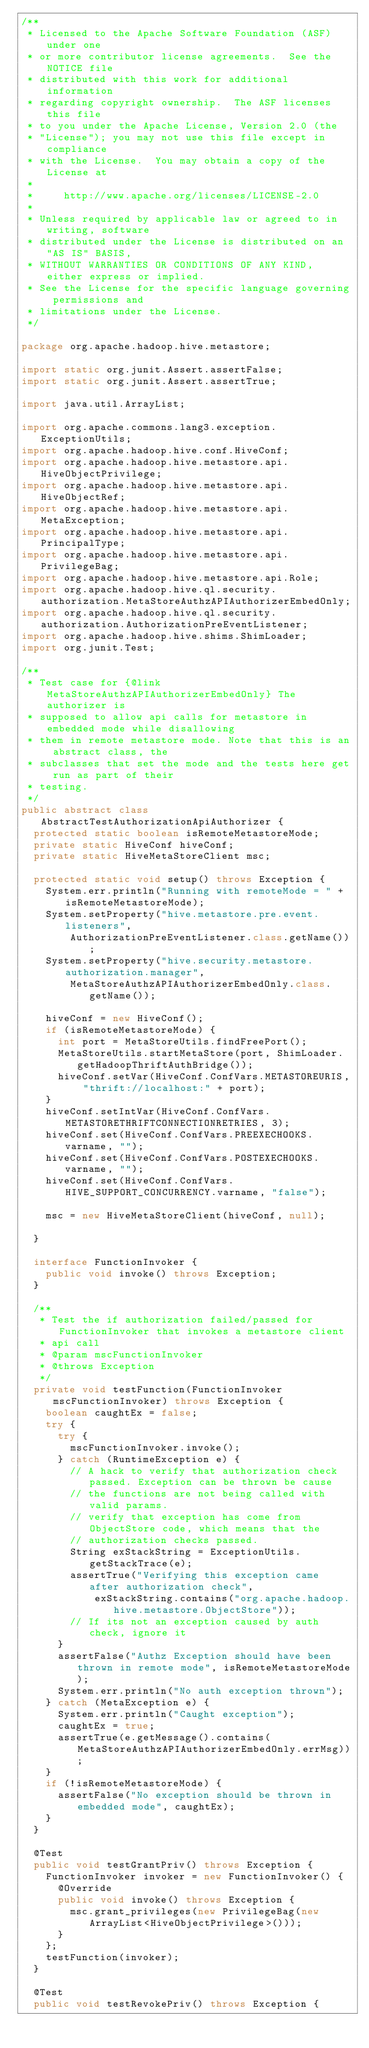Convert code to text. <code><loc_0><loc_0><loc_500><loc_500><_Java_>/**
 * Licensed to the Apache Software Foundation (ASF) under one
 * or more contributor license agreements.  See the NOTICE file
 * distributed with this work for additional information
 * regarding copyright ownership.  The ASF licenses this file
 * to you under the Apache License, Version 2.0 (the
 * "License"); you may not use this file except in compliance
 * with the License.  You may obtain a copy of the License at
 *
 *     http://www.apache.org/licenses/LICENSE-2.0
 *
 * Unless required by applicable law or agreed to in writing, software
 * distributed under the License is distributed on an "AS IS" BASIS,
 * WITHOUT WARRANTIES OR CONDITIONS OF ANY KIND, either express or implied.
 * See the License for the specific language governing permissions and
 * limitations under the License.
 */

package org.apache.hadoop.hive.metastore;

import static org.junit.Assert.assertFalse;
import static org.junit.Assert.assertTrue;

import java.util.ArrayList;

import org.apache.commons.lang3.exception.ExceptionUtils;
import org.apache.hadoop.hive.conf.HiveConf;
import org.apache.hadoop.hive.metastore.api.HiveObjectPrivilege;
import org.apache.hadoop.hive.metastore.api.HiveObjectRef;
import org.apache.hadoop.hive.metastore.api.MetaException;
import org.apache.hadoop.hive.metastore.api.PrincipalType;
import org.apache.hadoop.hive.metastore.api.PrivilegeBag;
import org.apache.hadoop.hive.metastore.api.Role;
import org.apache.hadoop.hive.ql.security.authorization.MetaStoreAuthzAPIAuthorizerEmbedOnly;
import org.apache.hadoop.hive.ql.security.authorization.AuthorizationPreEventListener;
import org.apache.hadoop.hive.shims.ShimLoader;
import org.junit.Test;

/**
 * Test case for {@link MetaStoreAuthzAPIAuthorizerEmbedOnly} The authorizer is
 * supposed to allow api calls for metastore in embedded mode while disallowing
 * them in remote metastore mode. Note that this is an abstract class, the
 * subclasses that set the mode and the tests here get run as part of their
 * testing.
 */
public abstract class AbstractTestAuthorizationApiAuthorizer {
  protected static boolean isRemoteMetastoreMode;
  private static HiveConf hiveConf;
  private static HiveMetaStoreClient msc;

  protected static void setup() throws Exception {
    System.err.println("Running with remoteMode = " + isRemoteMetastoreMode);
    System.setProperty("hive.metastore.pre.event.listeners",
        AuthorizationPreEventListener.class.getName());
    System.setProperty("hive.security.metastore.authorization.manager",
        MetaStoreAuthzAPIAuthorizerEmbedOnly.class.getName());

    hiveConf = new HiveConf();
    if (isRemoteMetastoreMode) {
      int port = MetaStoreUtils.findFreePort();
      MetaStoreUtils.startMetaStore(port, ShimLoader.getHadoopThriftAuthBridge());
      hiveConf.setVar(HiveConf.ConfVars.METASTOREURIS, "thrift://localhost:" + port);
    }
    hiveConf.setIntVar(HiveConf.ConfVars.METASTORETHRIFTCONNECTIONRETRIES, 3);
    hiveConf.set(HiveConf.ConfVars.PREEXECHOOKS.varname, "");
    hiveConf.set(HiveConf.ConfVars.POSTEXECHOOKS.varname, "");
    hiveConf.set(HiveConf.ConfVars.HIVE_SUPPORT_CONCURRENCY.varname, "false");

    msc = new HiveMetaStoreClient(hiveConf, null);

  }

  interface FunctionInvoker {
    public void invoke() throws Exception;
  }

  /**
   * Test the if authorization failed/passed for FunctionInvoker that invokes a metastore client
   * api call
   * @param mscFunctionInvoker
   * @throws Exception
   */
  private void testFunction(FunctionInvoker mscFunctionInvoker) throws Exception {
    boolean caughtEx = false;
    try {
      try {
        mscFunctionInvoker.invoke();
      } catch (RuntimeException e) {
        // A hack to verify that authorization check passed. Exception can be thrown be cause
        // the functions are not being called with valid params.
        // verify that exception has come from ObjectStore code, which means that the
        // authorization checks passed.
        String exStackString = ExceptionUtils.getStackTrace(e);
        assertTrue("Verifying this exception came after authorization check",
            exStackString.contains("org.apache.hadoop.hive.metastore.ObjectStore"));
        // If its not an exception caused by auth check, ignore it
      }
      assertFalse("Authz Exception should have been thrown in remote mode", isRemoteMetastoreMode);
      System.err.println("No auth exception thrown");
    } catch (MetaException e) {
      System.err.println("Caught exception");
      caughtEx = true;
      assertTrue(e.getMessage().contains(MetaStoreAuthzAPIAuthorizerEmbedOnly.errMsg));
    }
    if (!isRemoteMetastoreMode) {
      assertFalse("No exception should be thrown in embedded mode", caughtEx);
    }
  }

  @Test
  public void testGrantPriv() throws Exception {
    FunctionInvoker invoker = new FunctionInvoker() {
      @Override
      public void invoke() throws Exception {
        msc.grant_privileges(new PrivilegeBag(new ArrayList<HiveObjectPrivilege>()));
      }
    };
    testFunction(invoker);
  }

  @Test
  public void testRevokePriv() throws Exception {</code> 